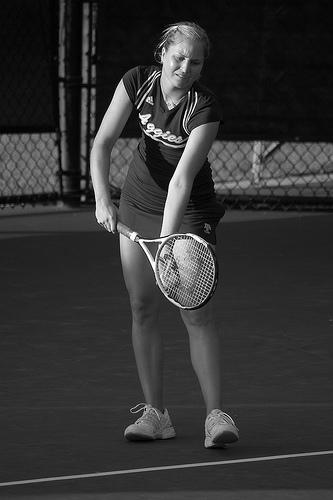Question: what is she holding?
Choices:
A. A beer mug.
B. An umbrella.
C. A ticket.
D. A racket.
Answer with the letter. Answer: D Question: what is she wearing?
Choices:
A. A wet suit.
B. A football helmet.
C. A wedding dress.
D. Tennis gear.
Answer with the letter. Answer: D Question: what game is being played?
Choices:
A. Tennis.
B. Soccer.
C. Baseball.
D. Football.
Answer with the letter. Answer: A Question: where was the photo taken?
Choices:
A. Soccer field.
B. Tennis court.
C. Baseball mound.
D. Football field.
Answer with the letter. Answer: B 